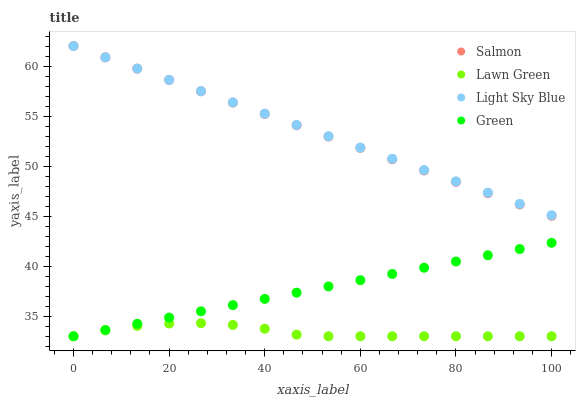Does Lawn Green have the minimum area under the curve?
Answer yes or no. Yes. Does Light Sky Blue have the maximum area under the curve?
Answer yes or no. Yes. Does Salmon have the minimum area under the curve?
Answer yes or no. No. Does Salmon have the maximum area under the curve?
Answer yes or no. No. Is Salmon the smoothest?
Answer yes or no. Yes. Is Lawn Green the roughest?
Answer yes or no. Yes. Is Light Sky Blue the smoothest?
Answer yes or no. No. Is Light Sky Blue the roughest?
Answer yes or no. No. Does Lawn Green have the lowest value?
Answer yes or no. Yes. Does Salmon have the lowest value?
Answer yes or no. No. Does Salmon have the highest value?
Answer yes or no. Yes. Does Green have the highest value?
Answer yes or no. No. Is Green less than Light Sky Blue?
Answer yes or no. Yes. Is Light Sky Blue greater than Green?
Answer yes or no. Yes. Does Salmon intersect Light Sky Blue?
Answer yes or no. Yes. Is Salmon less than Light Sky Blue?
Answer yes or no. No. Is Salmon greater than Light Sky Blue?
Answer yes or no. No. Does Green intersect Light Sky Blue?
Answer yes or no. No. 